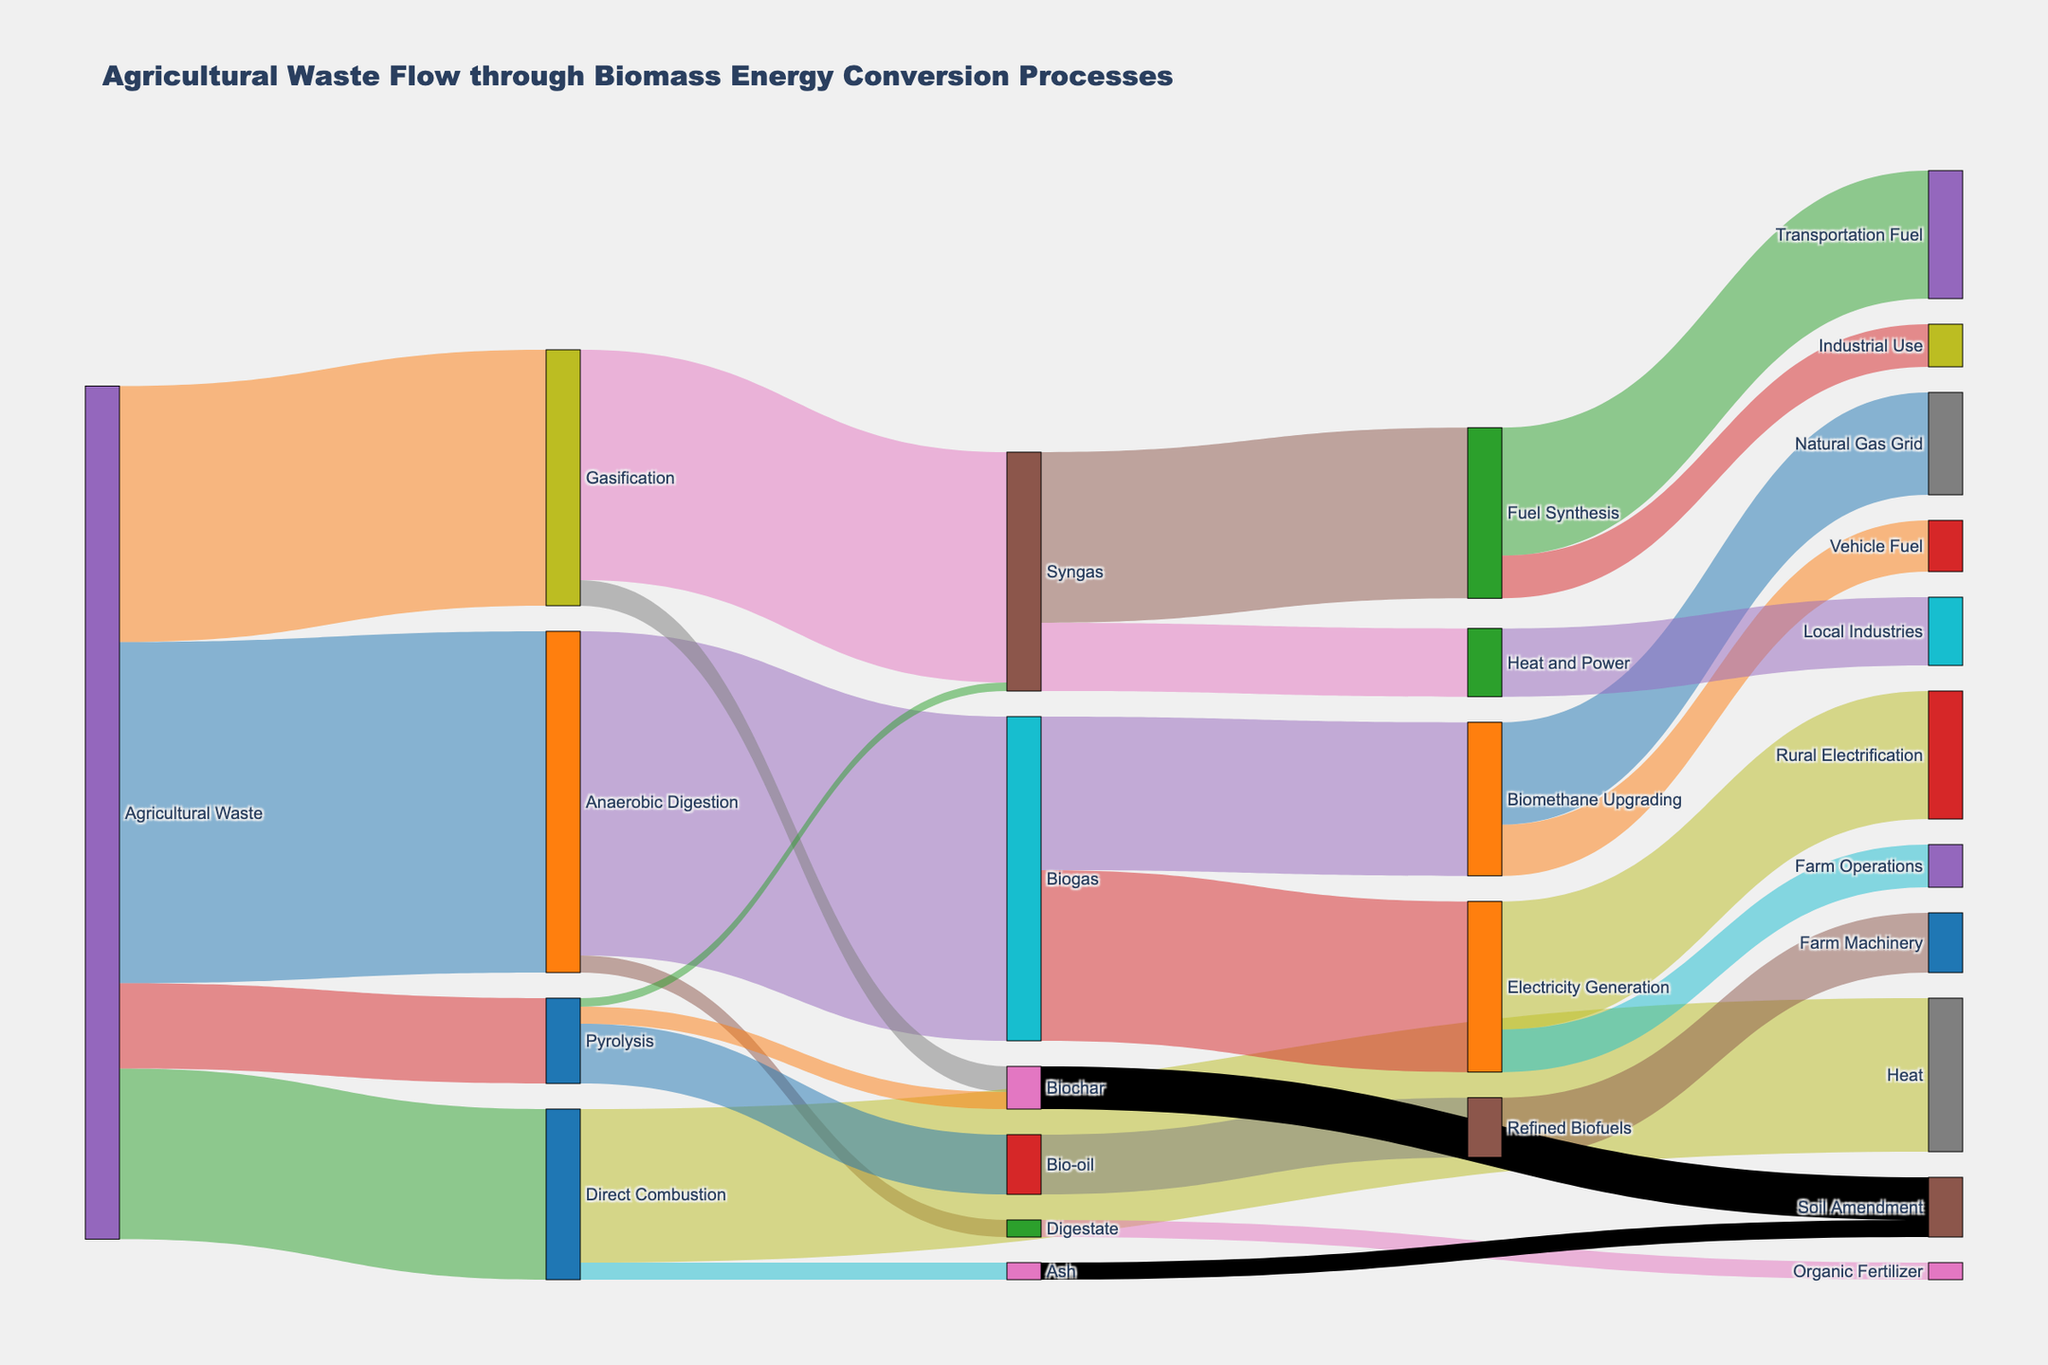What's the primary conversion process for Agricultural Waste? The Sankey diagram shows four primary conversion processes for agricultural waste. The one with the highest value indicates the primary process. By examining the input values for these processes, Anaerobic Digestion has the highest value (400).
Answer: Anaerobic Digestion What products are generated from Gasification of Agricultural Waste? By following the flow from Gasification in the Sankey diagram to its resulting targets, we see two products: Syngas with a value of 270 and Biochar with a value of 30.
Answer: Syngas and Biochar What is the total value of Agricultural Waste used for energy conversion processes? The total value of Agricultural Waste is the sum of the values of all primary conversion processes. This includes Anaerobic Digestion (400), Gasification (300), Direct Combustion (200), and Pyrolysis (100). Sum: 400 + 300 + 200 + 100 = 1000.
Answer: 1000 Which end product has the highest value from Biogas? From the diagram, Biogas leads to two end products: Electricity Generation with a value of 200 and Biomethane Upgrading with a value of 180. Comparing these values, Electricity Generation has the highest value.
Answer: Electricity Generation How much Organic Fertilizer is produced from Digestate? The diagram shows Digestate flowing only to Organic Fertilizer with a value of 20.
Answer: 20 Compare the value of Biochar produced from Pyrolysis and Gasification. Which is higher? Biochar is produced from both Pyrolysis and Gasification. From Pyrolysis, the value is 20, and from Gasification, the value is 30. Comparing these, Gasification produces more Biochar.
Answer: Gasification What is the total value of Renewable Energy products generated from Syngas? Following the flow from Syngas, it leads to Fuel Synthesis (200) and Heat and Power (80). Sum: 200 + 80 = 280.
Answer: 280 How much Heat is generated from Direct Combustion of Agricultural Waste? The Sankey diagram shows Direct Combustion leading to Heat with a value of 180.
Answer: 180 What conversion process has the smallest contribution to final products? Among the primary processes, the smallest value is for Pyrolysis, with a value of 100.
Answer: Pyrolysis Which component contributes more to Soil Amendment, Biochar or Ash? The diagram shows both Biochar and Ash flowing to Soil Amendment. Biochar with a value of 50 and Ash with a value of 20. Thus, Biochar contributes more.
Answer: Biochar 